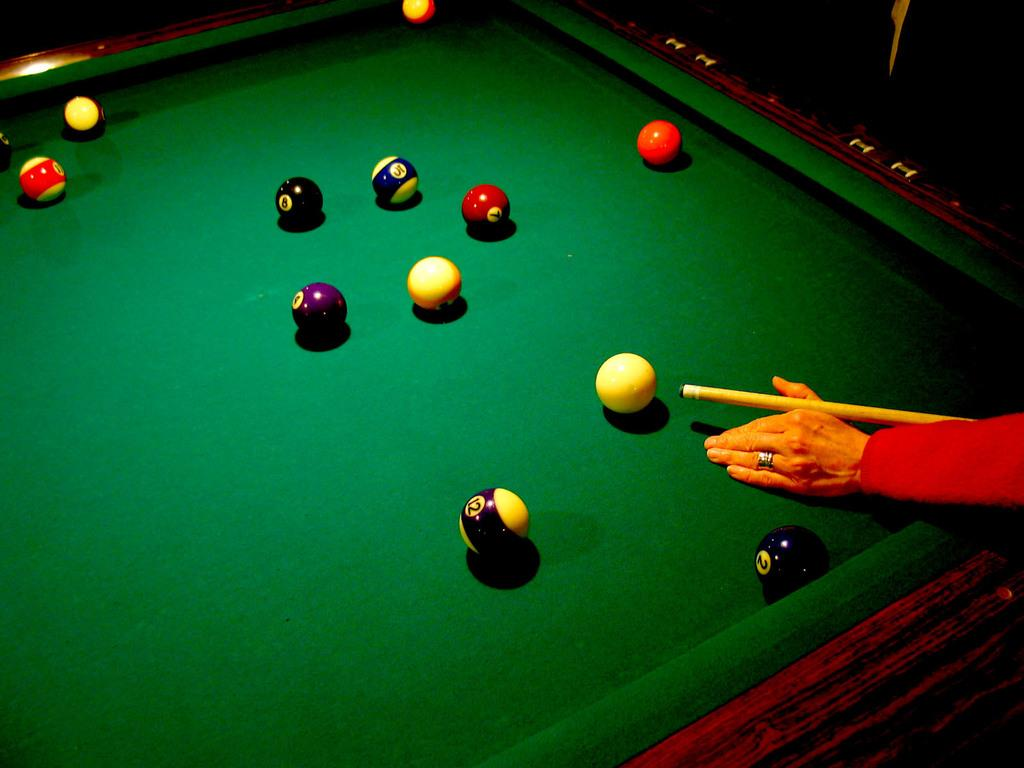What type of table is shown in the image? There is a ball pool table in the image. How are the balls arranged on the table? All the balls are placed on the table. What is the person in the image doing? There is a human hand holding a stick to hit the ball. Where is the hand positioned in relation to the table? The hand is positioned to the right of the table. What type of meat is being flavored by the hand in the image? There is no meat or flavoring present in the image; it features a ball pool table with a hand holding a stick to hit the ball. 